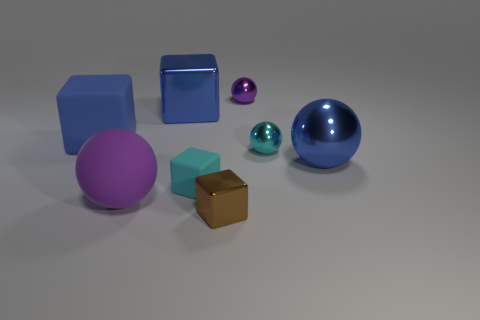What is the material of the other block that is the same color as the large metal block?
Your answer should be compact. Rubber. How many objects are either things right of the tiny purple metallic ball or small metal balls?
Keep it short and to the point. 3. The big metal object that is in front of the big blue rubber cube has what shape?
Offer a terse response. Sphere. Is the number of tiny cyan objects that are left of the big blue rubber object the same as the number of tiny cyan rubber things that are behind the purple matte object?
Give a very brief answer. No. There is a metallic sphere that is in front of the purple metal thing and left of the large metallic sphere; what is its color?
Offer a very short reply. Cyan. There is a big block on the left side of the large sphere in front of the tiny cyan cube; what is its material?
Offer a terse response. Rubber. Is the purple matte ball the same size as the brown block?
Provide a short and direct response. No. How many large things are either brown things or cyan spheres?
Your response must be concise. 0. There is a big purple object; what number of tiny brown things are to the right of it?
Offer a very short reply. 1. Are there more big objects in front of the big blue shiny sphere than blue metallic cubes?
Ensure brevity in your answer.  No. 